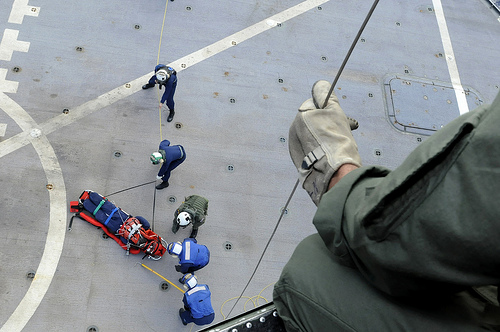<image>
Is the glove on the man? No. The glove is not positioned on the man. They may be near each other, but the glove is not supported by or resting on top of the man. 